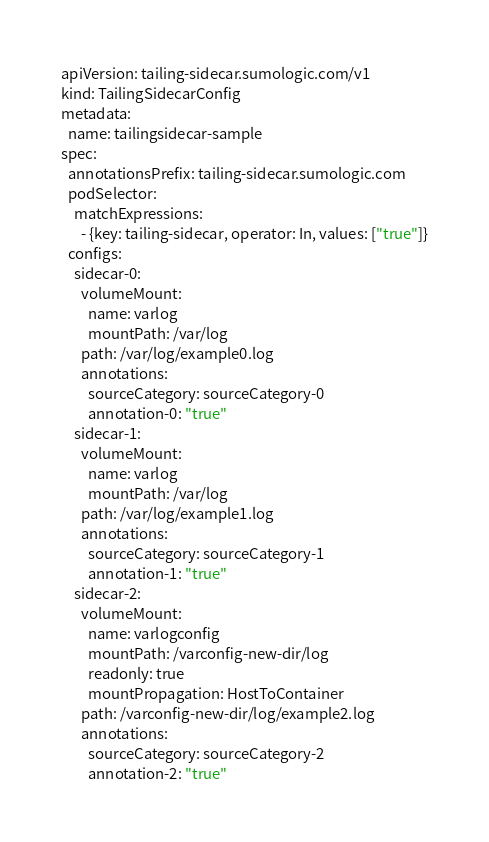Convert code to text. <code><loc_0><loc_0><loc_500><loc_500><_YAML_>apiVersion: tailing-sidecar.sumologic.com/v1
kind: TailingSidecarConfig
metadata:
  name: tailingsidecar-sample
spec:
  annotationsPrefix: tailing-sidecar.sumologic.com
  podSelector:
    matchExpressions:
      - {key: tailing-sidecar, operator: In, values: ["true"]}
  configs:
    sidecar-0:
      volumeMount:
        name: varlog
        mountPath: /var/log
      path: /var/log/example0.log
      annotations:
        sourceCategory: sourceCategory-0
        annotation-0: "true"
    sidecar-1:
      volumeMount:
        name: varlog
        mountPath: /var/log
      path: /var/log/example1.log
      annotations:
        sourceCategory: sourceCategory-1
        annotation-1: "true"
    sidecar-2:
      volumeMount:
        name: varlogconfig
        mountPath: /varconfig-new-dir/log
        readonly: true
        mountPropagation: HostToContainer
      path: /varconfig-new-dir/log/example2.log
      annotations:
        sourceCategory: sourceCategory-2
        annotation-2: "true"
</code> 